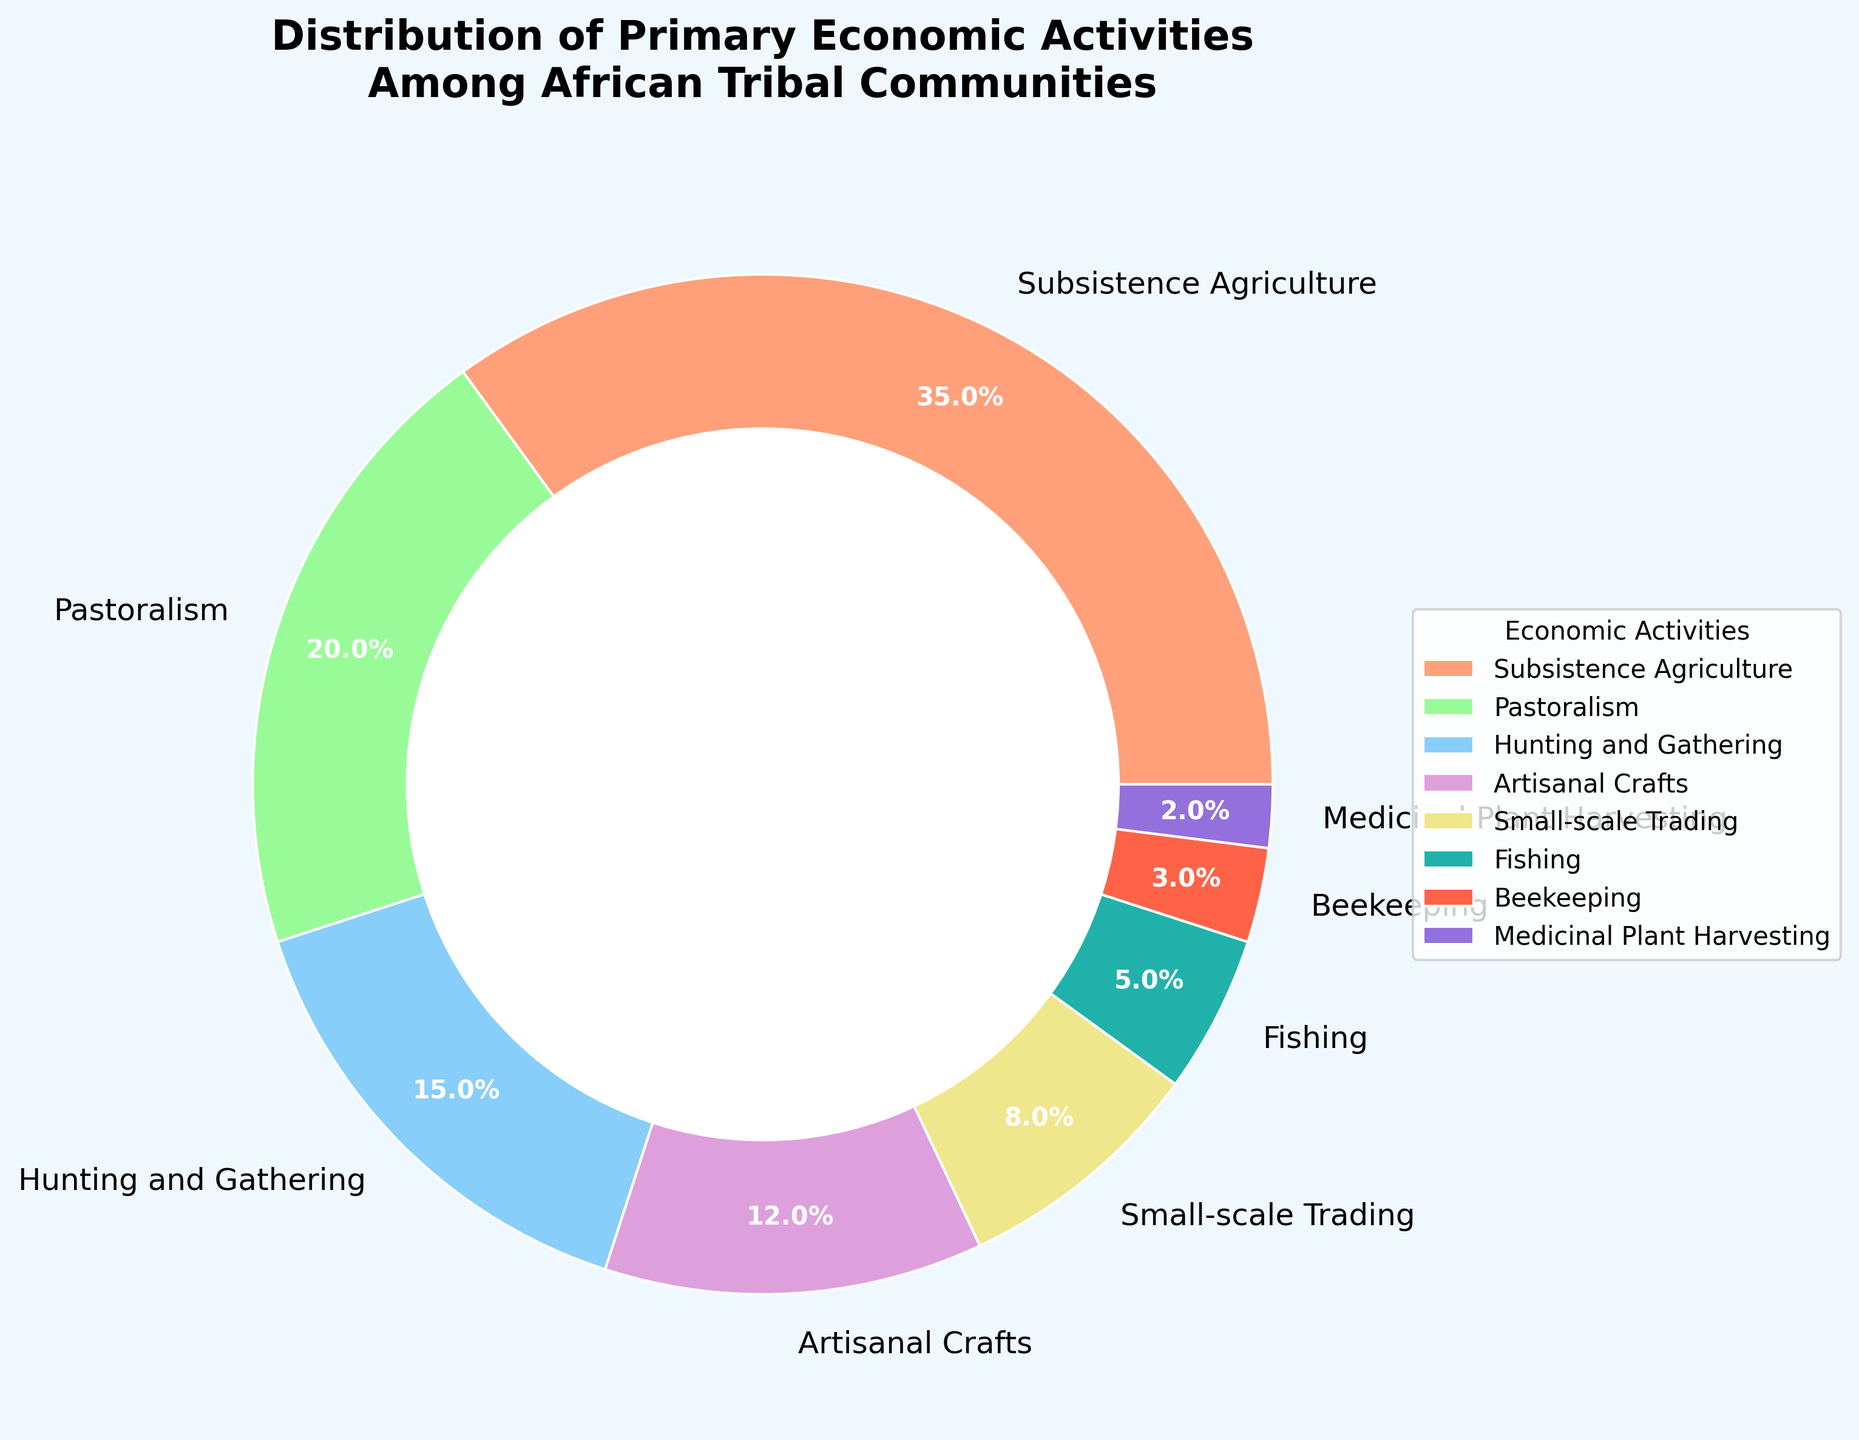What's the most common primary economic activity among African tribal communities? The pie chart shows that the largest segment, representing 35%, is for Subsistence Agriculture. Therefore, Subsistence Agriculture is the most common primary economic activity among African tribal communities.
Answer: Subsistence Agriculture Which economic activity has the smallest percentage in the distribution? By looking at the size of the segments, the smallest segment is 2%, which corresponds to Medicinal Plant Harvesting.
Answer: Medicinal Plant Harvesting How much greater is the percentage of Pastoralism compared to Subsistence Agriculture? Pastoralism accounts for 20% whereas Subsistence Agriculture accounts for 35%. The difference is calculated by 35% - 20%.
Answer: 15% What is the combined percentage of Artisanal Crafts and Small-scale Trading? Artisanal Crafts make up 12% and Small-scale Trading makes up 8%. Summing these percentages gives 12% + 8%.
Answer: 20% Which of the activities has a percentage closest to 10%? By examining the segments close to 10%, Artisanal Crafts with 12% is the closest.
Answer: Artisanal Crafts Arrange Pastoralism, Fishing, and Beekeeping in descending order of their percentages. The percentages for Pastoralism, Fishing, and Beekeeping are 20%, 5%, and 3% respectively. Arranging them in descending order yields: Pastoralism > Fishing > Beekeeping.
Answer: Pastoralism > Fishing > Beekeeping What percentage of activities other than Subsistence Agriculture and Pastoralism constitute together? Subsistence Agriculture and Pastoralism together account for 35% + 20% = 55%. The total percentage is 100%, so the remainder is 100% - 55%.
Answer: 45% Which economic activity is represented by the green segment in the chart? The pie chart's green segment corresponds to 20%, which represents Pastoralism activities.
Answer: Pastoralism What is the average percentage of Hunting and Gathering, Fishing, and Beekeeping combined? Hunting and Gathering is 15%, Fishing is 5%, and Beekeeping is 3%. Summing them up gives 15% + 5% + 3% = 23%. Since there are three activities, the average is 23% / 3.
Answer: 7.67% If you combine the percentages of Beekeeping and Medicinal Plant Harvesting, is their total higher than Fishing? Beekeeping is 3% and Medicinal Plant Harvesting is 2%. Together they make 3% + 2% = 5%, which is equal to the percentage for Fishing (5%).
Answer: No 